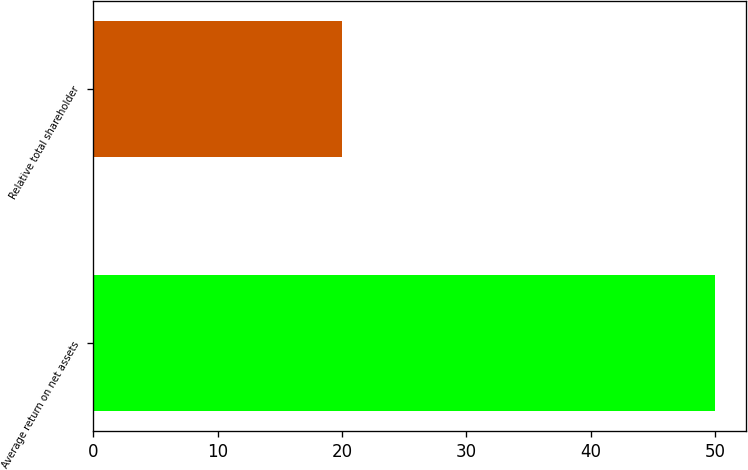<chart> <loc_0><loc_0><loc_500><loc_500><bar_chart><fcel>Average return on net assets<fcel>Relative total shareholder<nl><fcel>50<fcel>20<nl></chart> 